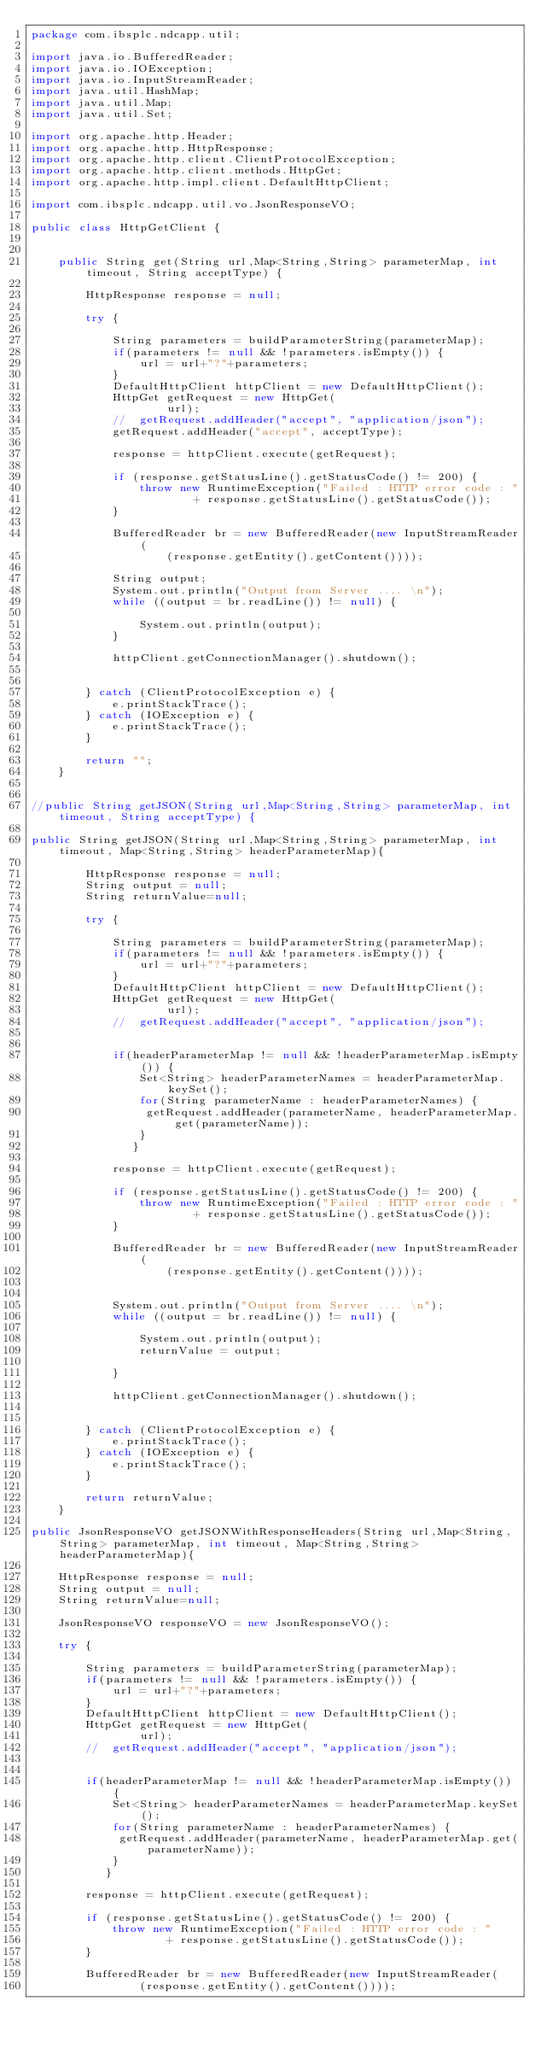<code> <loc_0><loc_0><loc_500><loc_500><_Java_>package com.ibsplc.ndcapp.util;

import java.io.BufferedReader;
import java.io.IOException;
import java.io.InputStreamReader;
import java.util.HashMap;
import java.util.Map;
import java.util.Set;

import org.apache.http.Header;
import org.apache.http.HttpResponse;
import org.apache.http.client.ClientProtocolException;
import org.apache.http.client.methods.HttpGet;
import org.apache.http.impl.client.DefaultHttpClient;

import com.ibsplc.ndcapp.util.vo.JsonResponseVO;

public class HttpGetClient {

	
	public String get(String url,Map<String,String> parameterMap, int timeout, String acceptType) {
		
		HttpResponse response = null;
				
		try {

			String parameters = buildParameterString(parameterMap);
			if(parameters != null && !parameters.isEmpty()) {
				url = url+"?"+parameters;
			}
			DefaultHttpClient httpClient = new DefaultHttpClient();
			HttpGet getRequest = new HttpGet(
					url);
			//	getRequest.addHeader("accept", "application/json");
			getRequest.addHeader("accept", acceptType);			

			response = httpClient.execute(getRequest);

			if (response.getStatusLine().getStatusCode() != 200) {
				throw new RuntimeException("Failed : HTTP error code : "
						+ response.getStatusLine().getStatusCode());
			}

			BufferedReader br = new BufferedReader(new InputStreamReader(
					(response.getEntity().getContent())));

			String output;
			System.out.println("Output from Server .... \n");
			while ((output = br.readLine()) != null) {

				System.out.println(output);
			}

			httpClient.getConnectionManager().shutdown();
			

		} catch (ClientProtocolException e) {
			e.printStackTrace();
		} catch (IOException e) {
			e.printStackTrace();
		}
		
		return "";
	}

	
//public String getJSON(String url,Map<String,String> parameterMap, int timeout, String acceptType) {
		
public String getJSON(String url,Map<String,String> parameterMap, int timeout, Map<String,String> headerParameterMap){
	
		HttpResponse response = null;
		String output = null;
		String returnValue=null;

		try {

			String parameters = buildParameterString(parameterMap);
			if(parameters != null && !parameters.isEmpty()) {
				url = url+"?"+parameters;
			}
			DefaultHttpClient httpClient = new DefaultHttpClient();
			HttpGet getRequest = new HttpGet(
					url);
			//	getRequest.addHeader("accept", "application/json");
			
		    
			if(headerParameterMap != null && !headerParameterMap.isEmpty()) {
			    Set<String> headerParameterNames = headerParameterMap.keySet();
			    for(String parameterName : headerParameterNames) {
			     getRequest.addHeader(parameterName, headerParameterMap.get(parameterName));  
			    }
			   }

			response = httpClient.execute(getRequest);

			if (response.getStatusLine().getStatusCode() != 200) {
				throw new RuntimeException("Failed : HTTP error code : "
						+ response.getStatusLine().getStatusCode());
			}

			BufferedReader br = new BufferedReader(new InputStreamReader(
					(response.getEntity().getContent())));

			
			System.out.println("Output from Server .... \n");
			while ((output = br.readLine()) != null) {

				System.out.println(output);
				returnValue = output;

			}

			httpClient.getConnectionManager().shutdown();
			

		} catch (ClientProtocolException e) {
			e.printStackTrace();
		} catch (IOException e) {
			e.printStackTrace();
		}
 
		return returnValue;
	}

public JsonResponseVO getJSONWithResponseHeaders(String url,Map<String,String> parameterMap, int timeout, Map<String,String> headerParameterMap){
	
	HttpResponse response = null;
	String output = null;
	String returnValue=null;
	
	JsonResponseVO responseVO = new JsonResponseVO();

	try {

		String parameters = buildParameterString(parameterMap);
		if(parameters != null && !parameters.isEmpty()) {
			url = url+"?"+parameters;
		}
		DefaultHttpClient httpClient = new DefaultHttpClient();
		HttpGet getRequest = new HttpGet(
				url);
		//	getRequest.addHeader("accept", "application/json");
		
	    
		if(headerParameterMap != null && !headerParameterMap.isEmpty()) {
		    Set<String> headerParameterNames = headerParameterMap.keySet();
		    for(String parameterName : headerParameterNames) {
		     getRequest.addHeader(parameterName, headerParameterMap.get(parameterName));  
		    }
		   }

		response = httpClient.execute(getRequest);

		if (response.getStatusLine().getStatusCode() != 200) {
			throw new RuntimeException("Failed : HTTP error code : "
					+ response.getStatusLine().getStatusCode());
		}

		BufferedReader br = new BufferedReader(new InputStreamReader(
				(response.getEntity().getContent())));

		</code> 